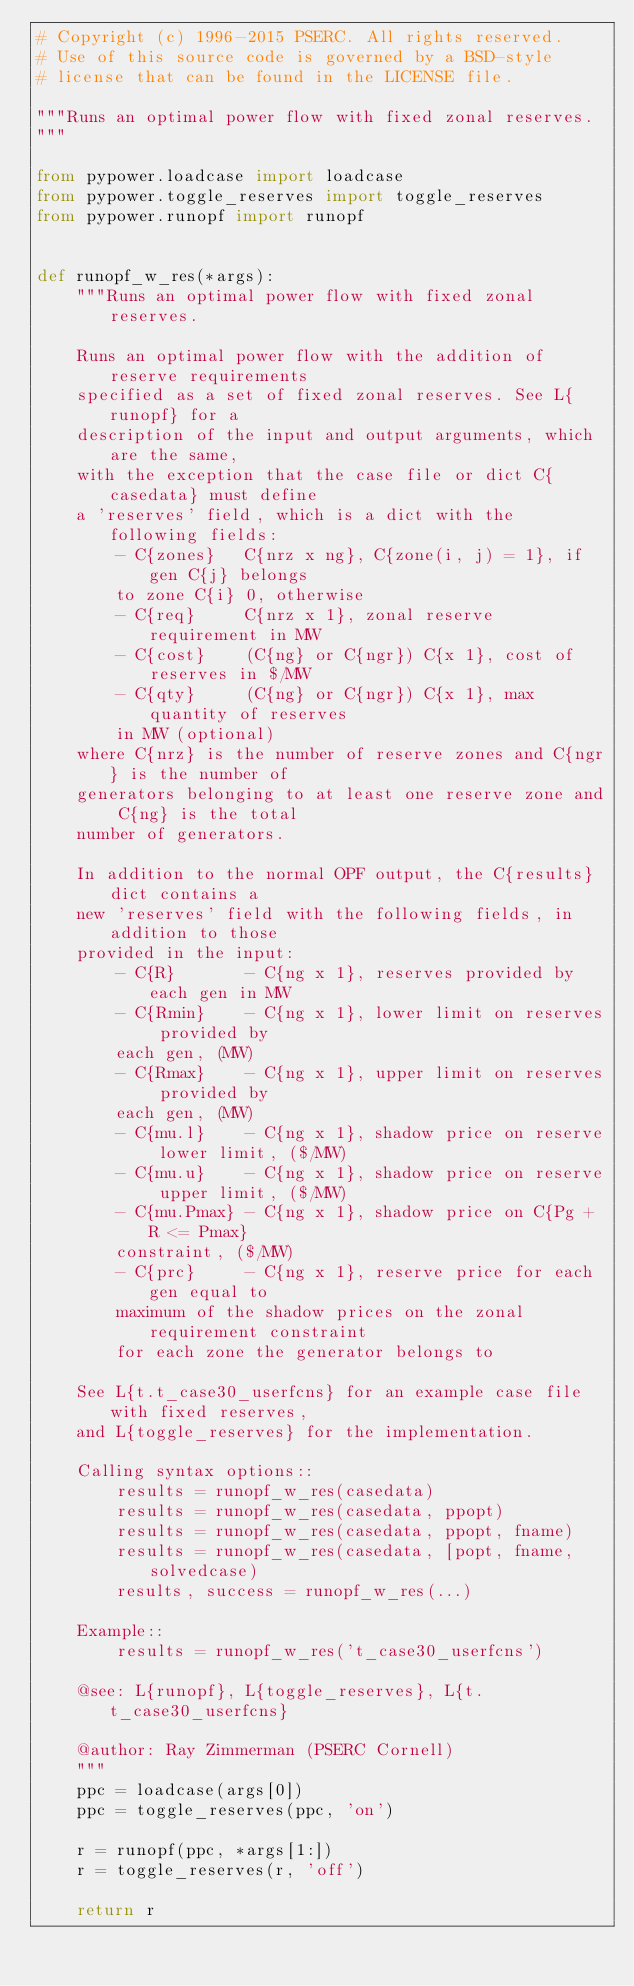Convert code to text. <code><loc_0><loc_0><loc_500><loc_500><_Python_># Copyright (c) 1996-2015 PSERC. All rights reserved.
# Use of this source code is governed by a BSD-style
# license that can be found in the LICENSE file.

"""Runs an optimal power flow with fixed zonal reserves.
"""

from pypower.loadcase import loadcase
from pypower.toggle_reserves import toggle_reserves
from pypower.runopf import runopf


def runopf_w_res(*args):
    """Runs an optimal power flow with fixed zonal reserves.

    Runs an optimal power flow with the addition of reserve requirements
    specified as a set of fixed zonal reserves. See L{runopf} for a
    description of the input and output arguments, which are the same,
    with the exception that the case file or dict C{casedata} must define
    a 'reserves' field, which is a dict with the following fields:
        - C{zones}   C{nrz x ng}, C{zone(i, j) = 1}, if gen C{j} belongs
        to zone C{i} 0, otherwise
        - C{req}     C{nrz x 1}, zonal reserve requirement in MW
        - C{cost}    (C{ng} or C{ngr}) C{x 1}, cost of reserves in $/MW
        - C{qty}     (C{ng} or C{ngr}) C{x 1}, max quantity of reserves
        in MW (optional)
    where C{nrz} is the number of reserve zones and C{ngr} is the number of
    generators belonging to at least one reserve zone and C{ng} is the total
    number of generators.

    In addition to the normal OPF output, the C{results} dict contains a
    new 'reserves' field with the following fields, in addition to those
    provided in the input:
        - C{R}       - C{ng x 1}, reserves provided by each gen in MW
        - C{Rmin}    - C{ng x 1}, lower limit on reserves provided by
        each gen, (MW)
        - C{Rmax}    - C{ng x 1}, upper limit on reserves provided by
        each gen, (MW)
        - C{mu.l}    - C{ng x 1}, shadow price on reserve lower limit, ($/MW)
        - C{mu.u}    - C{ng x 1}, shadow price on reserve upper limit, ($/MW)
        - C{mu.Pmax} - C{ng x 1}, shadow price on C{Pg + R <= Pmax}
        constraint, ($/MW)
        - C{prc}     - C{ng x 1}, reserve price for each gen equal to
        maximum of the shadow prices on the zonal requirement constraint
        for each zone the generator belongs to

    See L{t.t_case30_userfcns} for an example case file with fixed reserves,
    and L{toggle_reserves} for the implementation.

    Calling syntax options::
        results = runopf_w_res(casedata)
        results = runopf_w_res(casedata, ppopt)
        results = runopf_w_res(casedata, ppopt, fname)
        results = runopf_w_res(casedata, [popt, fname, solvedcase)
        results, success = runopf_w_res(...)

    Example::
        results = runopf_w_res('t_case30_userfcns')

    @see: L{runopf}, L{toggle_reserves}, L{t.t_case30_userfcns}

    @author: Ray Zimmerman (PSERC Cornell)
    """
    ppc = loadcase(args[0])
    ppc = toggle_reserves(ppc, 'on')

    r = runopf(ppc, *args[1:])
    r = toggle_reserves(r, 'off')

    return r
</code> 